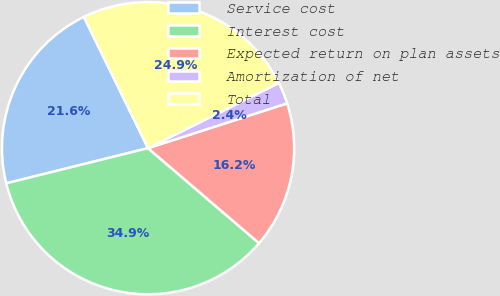Convert chart. <chart><loc_0><loc_0><loc_500><loc_500><pie_chart><fcel>Service cost<fcel>Interest cost<fcel>Expected return on plan assets<fcel>Amortization of net<fcel>Total<nl><fcel>21.63%<fcel>34.86%<fcel>16.23%<fcel>2.4%<fcel>24.88%<nl></chart> 